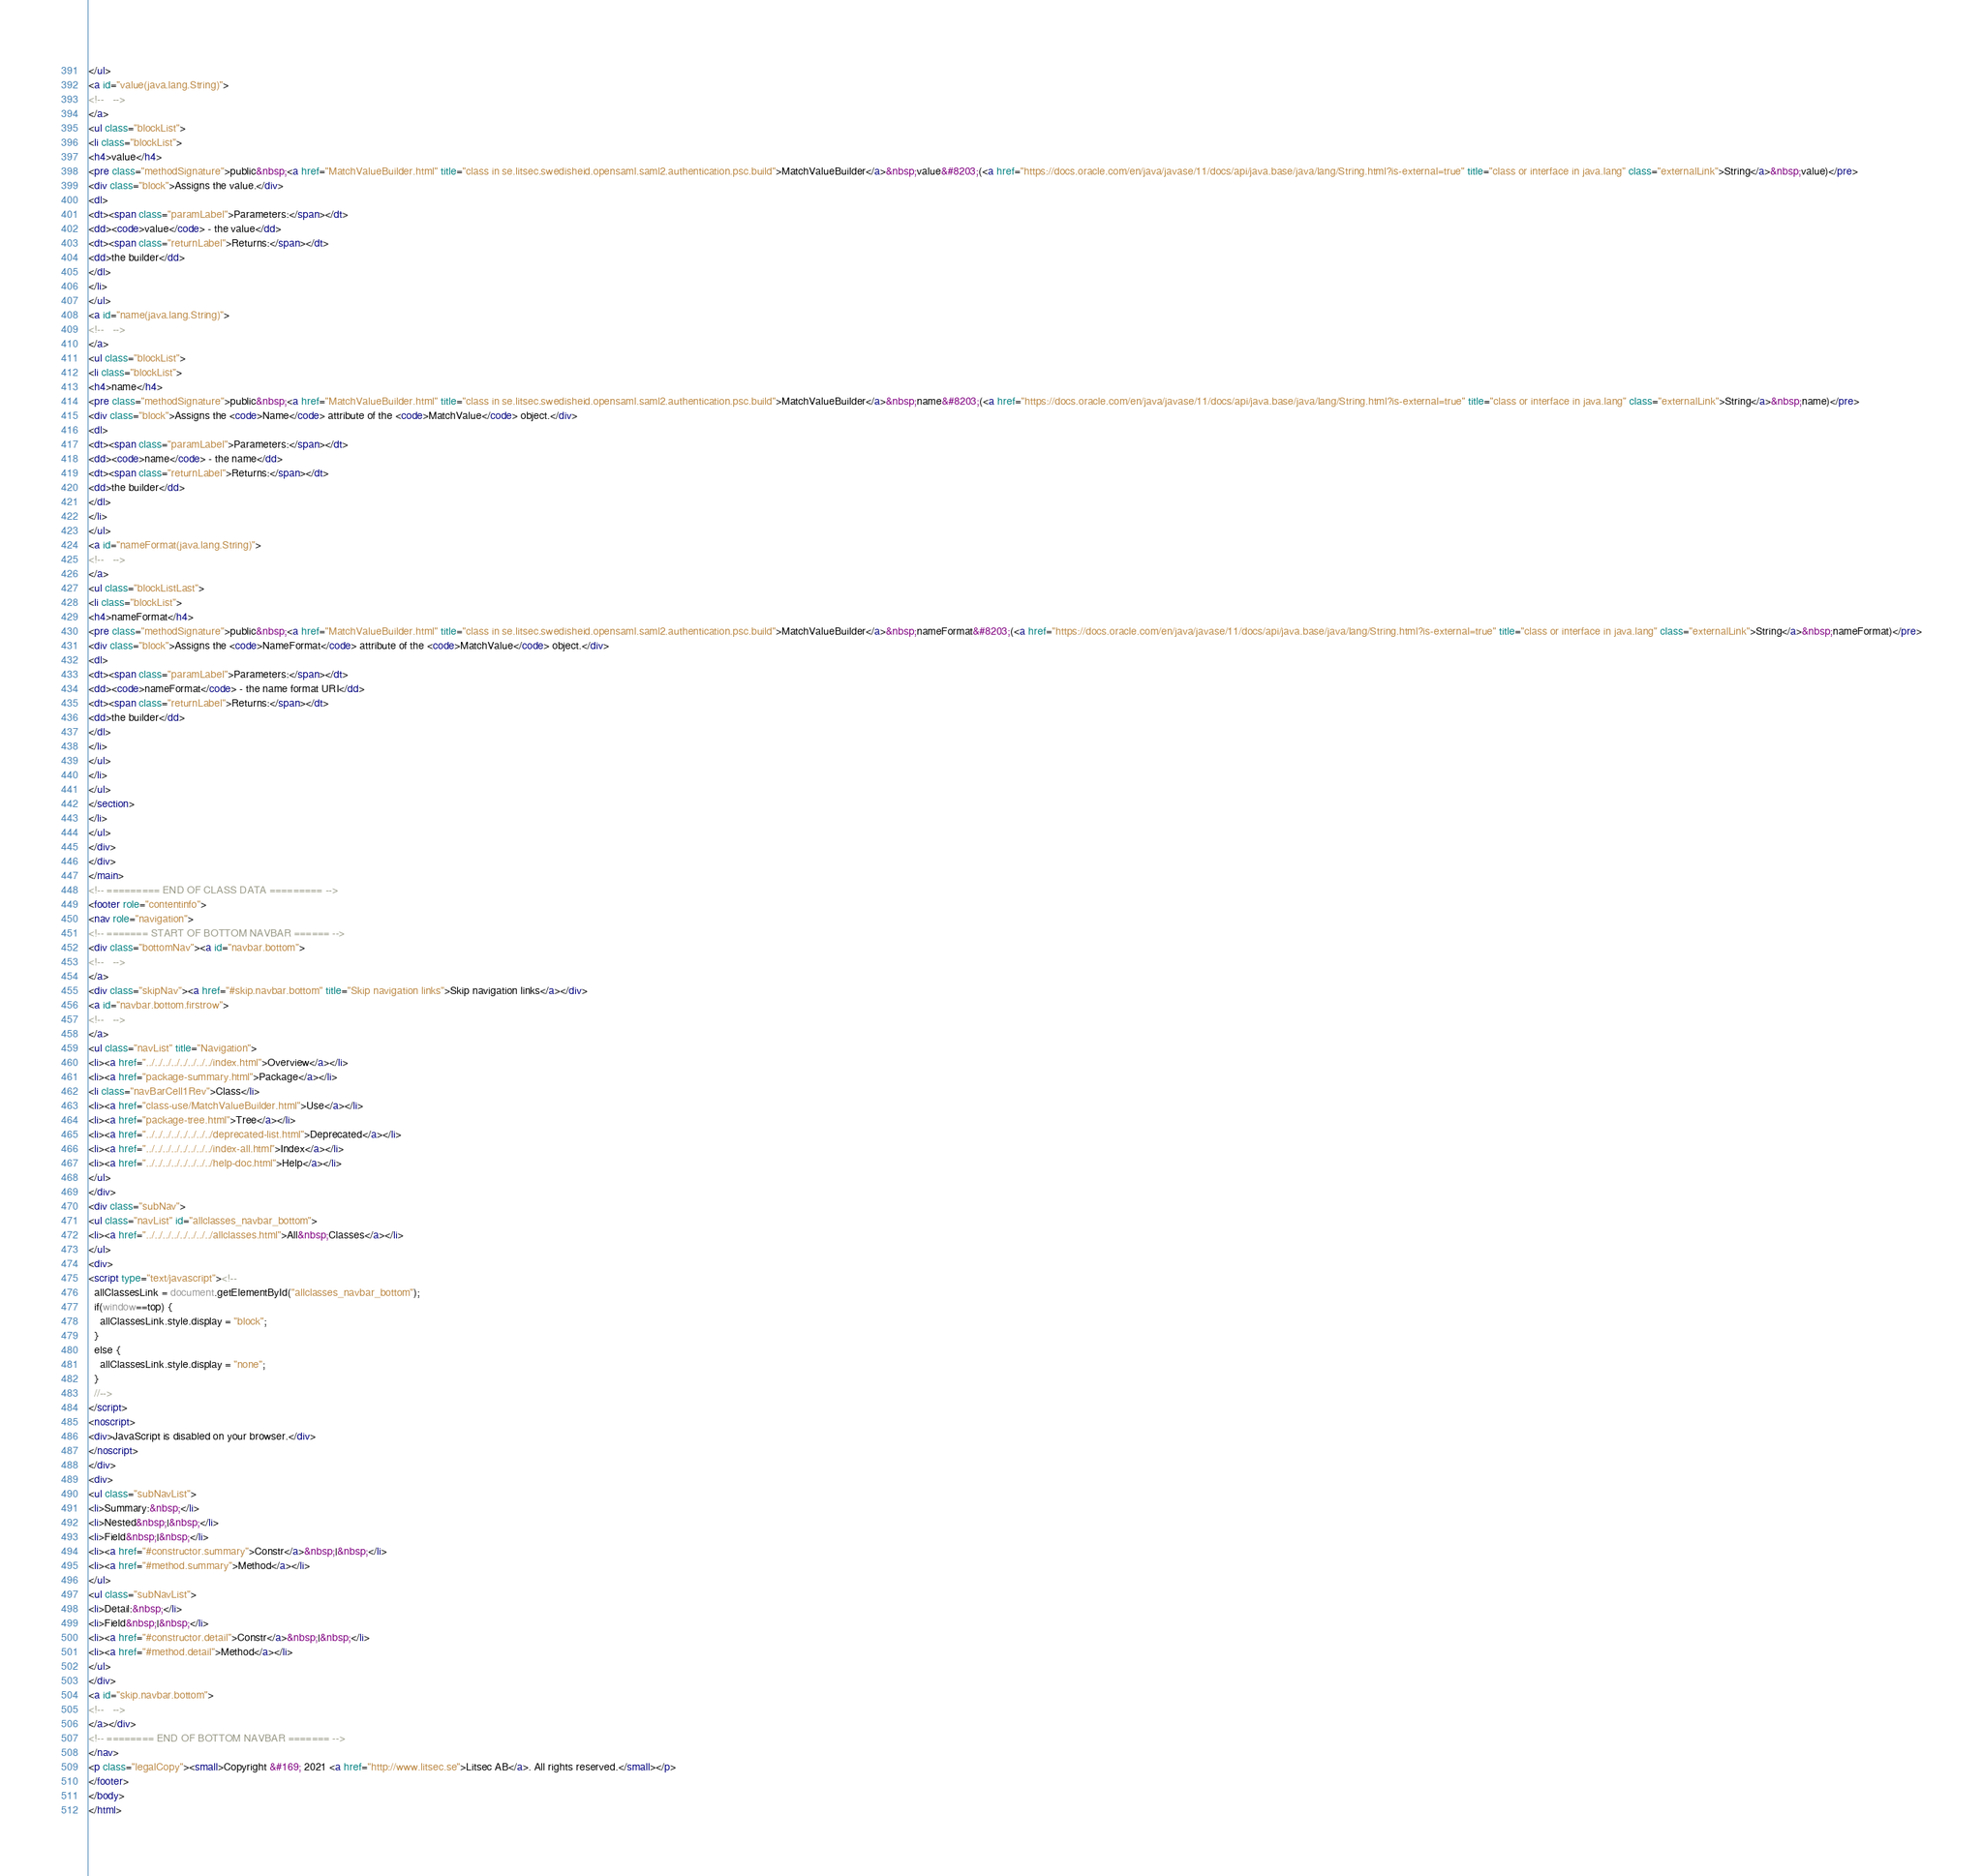<code> <loc_0><loc_0><loc_500><loc_500><_HTML_></ul>
<a id="value(java.lang.String)">
<!--   -->
</a>
<ul class="blockList">
<li class="blockList">
<h4>value</h4>
<pre class="methodSignature">public&nbsp;<a href="MatchValueBuilder.html" title="class in se.litsec.swedisheid.opensaml.saml2.authentication.psc.build">MatchValueBuilder</a>&nbsp;value&#8203;(<a href="https://docs.oracle.com/en/java/javase/11/docs/api/java.base/java/lang/String.html?is-external=true" title="class or interface in java.lang" class="externalLink">String</a>&nbsp;value)</pre>
<div class="block">Assigns the value.</div>
<dl>
<dt><span class="paramLabel">Parameters:</span></dt>
<dd><code>value</code> - the value</dd>
<dt><span class="returnLabel">Returns:</span></dt>
<dd>the builder</dd>
</dl>
</li>
</ul>
<a id="name(java.lang.String)">
<!--   -->
</a>
<ul class="blockList">
<li class="blockList">
<h4>name</h4>
<pre class="methodSignature">public&nbsp;<a href="MatchValueBuilder.html" title="class in se.litsec.swedisheid.opensaml.saml2.authentication.psc.build">MatchValueBuilder</a>&nbsp;name&#8203;(<a href="https://docs.oracle.com/en/java/javase/11/docs/api/java.base/java/lang/String.html?is-external=true" title="class or interface in java.lang" class="externalLink">String</a>&nbsp;name)</pre>
<div class="block">Assigns the <code>Name</code> attribute of the <code>MatchValue</code> object.</div>
<dl>
<dt><span class="paramLabel">Parameters:</span></dt>
<dd><code>name</code> - the name</dd>
<dt><span class="returnLabel">Returns:</span></dt>
<dd>the builder</dd>
</dl>
</li>
</ul>
<a id="nameFormat(java.lang.String)">
<!--   -->
</a>
<ul class="blockListLast">
<li class="blockList">
<h4>nameFormat</h4>
<pre class="methodSignature">public&nbsp;<a href="MatchValueBuilder.html" title="class in se.litsec.swedisheid.opensaml.saml2.authentication.psc.build">MatchValueBuilder</a>&nbsp;nameFormat&#8203;(<a href="https://docs.oracle.com/en/java/javase/11/docs/api/java.base/java/lang/String.html?is-external=true" title="class or interface in java.lang" class="externalLink">String</a>&nbsp;nameFormat)</pre>
<div class="block">Assigns the <code>NameFormat</code> attribute of the <code>MatchValue</code> object.</div>
<dl>
<dt><span class="paramLabel">Parameters:</span></dt>
<dd><code>nameFormat</code> - the name format URI</dd>
<dt><span class="returnLabel">Returns:</span></dt>
<dd>the builder</dd>
</dl>
</li>
</ul>
</li>
</ul>
</section>
</li>
</ul>
</div>
</div>
</main>
<!-- ========= END OF CLASS DATA ========= -->
<footer role="contentinfo">
<nav role="navigation">
<!-- ======= START OF BOTTOM NAVBAR ====== -->
<div class="bottomNav"><a id="navbar.bottom">
<!--   -->
</a>
<div class="skipNav"><a href="#skip.navbar.bottom" title="Skip navigation links">Skip navigation links</a></div>
<a id="navbar.bottom.firstrow">
<!--   -->
</a>
<ul class="navList" title="Navigation">
<li><a href="../../../../../../../../index.html">Overview</a></li>
<li><a href="package-summary.html">Package</a></li>
<li class="navBarCell1Rev">Class</li>
<li><a href="class-use/MatchValueBuilder.html">Use</a></li>
<li><a href="package-tree.html">Tree</a></li>
<li><a href="../../../../../../../../deprecated-list.html">Deprecated</a></li>
<li><a href="../../../../../../../../index-all.html">Index</a></li>
<li><a href="../../../../../../../../help-doc.html">Help</a></li>
</ul>
</div>
<div class="subNav">
<ul class="navList" id="allclasses_navbar_bottom">
<li><a href="../../../../../../../../allclasses.html">All&nbsp;Classes</a></li>
</ul>
<div>
<script type="text/javascript"><!--
  allClassesLink = document.getElementById("allclasses_navbar_bottom");
  if(window==top) {
    allClassesLink.style.display = "block";
  }
  else {
    allClassesLink.style.display = "none";
  }
  //-->
</script>
<noscript>
<div>JavaScript is disabled on your browser.</div>
</noscript>
</div>
<div>
<ul class="subNavList">
<li>Summary:&nbsp;</li>
<li>Nested&nbsp;|&nbsp;</li>
<li>Field&nbsp;|&nbsp;</li>
<li><a href="#constructor.summary">Constr</a>&nbsp;|&nbsp;</li>
<li><a href="#method.summary">Method</a></li>
</ul>
<ul class="subNavList">
<li>Detail:&nbsp;</li>
<li>Field&nbsp;|&nbsp;</li>
<li><a href="#constructor.detail">Constr</a>&nbsp;|&nbsp;</li>
<li><a href="#method.detail">Method</a></li>
</ul>
</div>
<a id="skip.navbar.bottom">
<!--   -->
</a></div>
<!-- ======== END OF BOTTOM NAVBAR ======= -->
</nav>
<p class="legalCopy"><small>Copyright &#169; 2021 <a href="http://www.litsec.se">Litsec AB</a>. All rights reserved.</small></p>
</footer>
</body>
</html>
</code> 